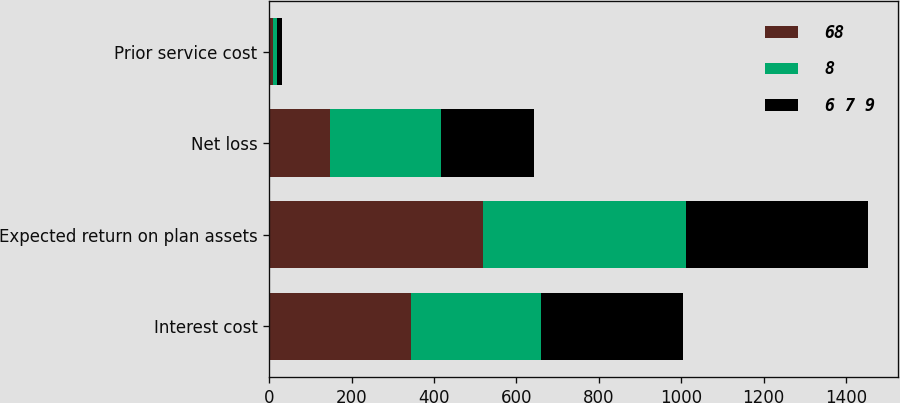<chart> <loc_0><loc_0><loc_500><loc_500><stacked_bar_chart><ecel><fcel>Interest cost<fcel>Expected return on plan assets<fcel>Net loss<fcel>Prior service cost<nl><fcel>68<fcel>345<fcel>518<fcel>147<fcel>10<nl><fcel>8<fcel>314<fcel>493<fcel>271<fcel>10<nl><fcel>6 7 9<fcel>344<fcel>442<fcel>224<fcel>10<nl></chart> 